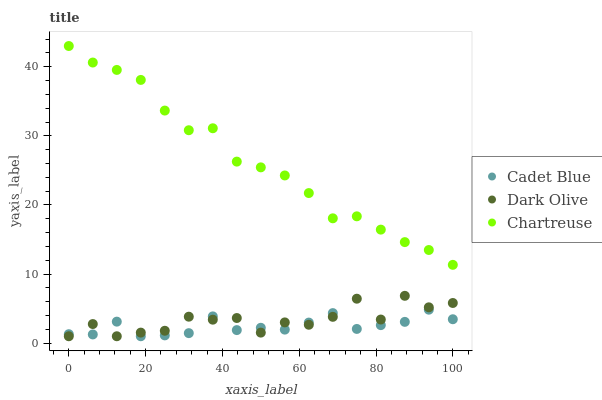Does Cadet Blue have the minimum area under the curve?
Answer yes or no. Yes. Does Chartreuse have the maximum area under the curve?
Answer yes or no. Yes. Does Chartreuse have the minimum area under the curve?
Answer yes or no. No. Does Cadet Blue have the maximum area under the curve?
Answer yes or no. No. Is Chartreuse the smoothest?
Answer yes or no. Yes. Is Dark Olive the roughest?
Answer yes or no. Yes. Is Cadet Blue the smoothest?
Answer yes or no. No. Is Cadet Blue the roughest?
Answer yes or no. No. Does Dark Olive have the lowest value?
Answer yes or no. Yes. Does Chartreuse have the lowest value?
Answer yes or no. No. Does Chartreuse have the highest value?
Answer yes or no. Yes. Does Cadet Blue have the highest value?
Answer yes or no. No. Is Dark Olive less than Chartreuse?
Answer yes or no. Yes. Is Chartreuse greater than Cadet Blue?
Answer yes or no. Yes. Does Cadet Blue intersect Dark Olive?
Answer yes or no. Yes. Is Cadet Blue less than Dark Olive?
Answer yes or no. No. Is Cadet Blue greater than Dark Olive?
Answer yes or no. No. Does Dark Olive intersect Chartreuse?
Answer yes or no. No. 